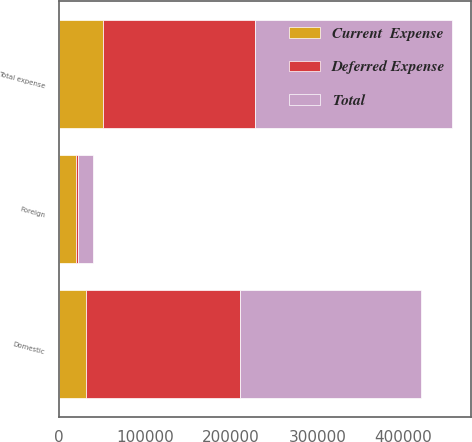Convert chart to OTSL. <chart><loc_0><loc_0><loc_500><loc_500><stacked_bar_chart><ecel><fcel>Domestic<fcel>Foreign<fcel>Total expense<nl><fcel>Deferred Expense<fcel>179150<fcel>2318<fcel>176832<nl><fcel>Current  Expense<fcel>31145<fcel>19946<fcel>51091<nl><fcel>Total<fcel>210295<fcel>17628<fcel>227923<nl></chart> 